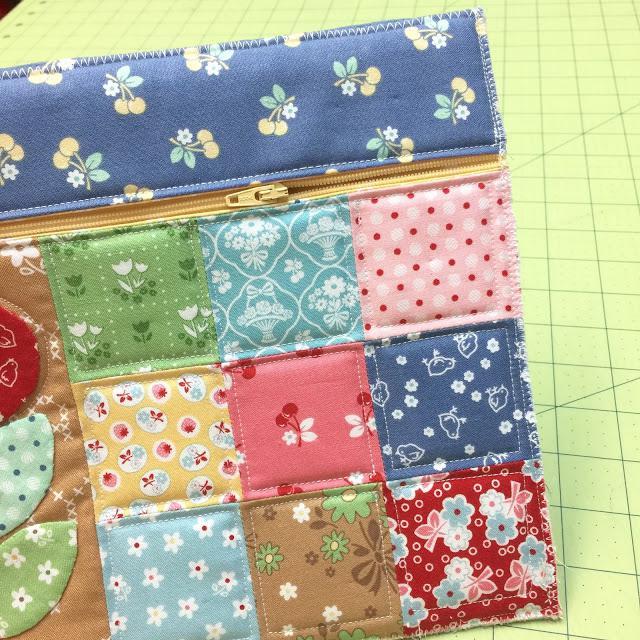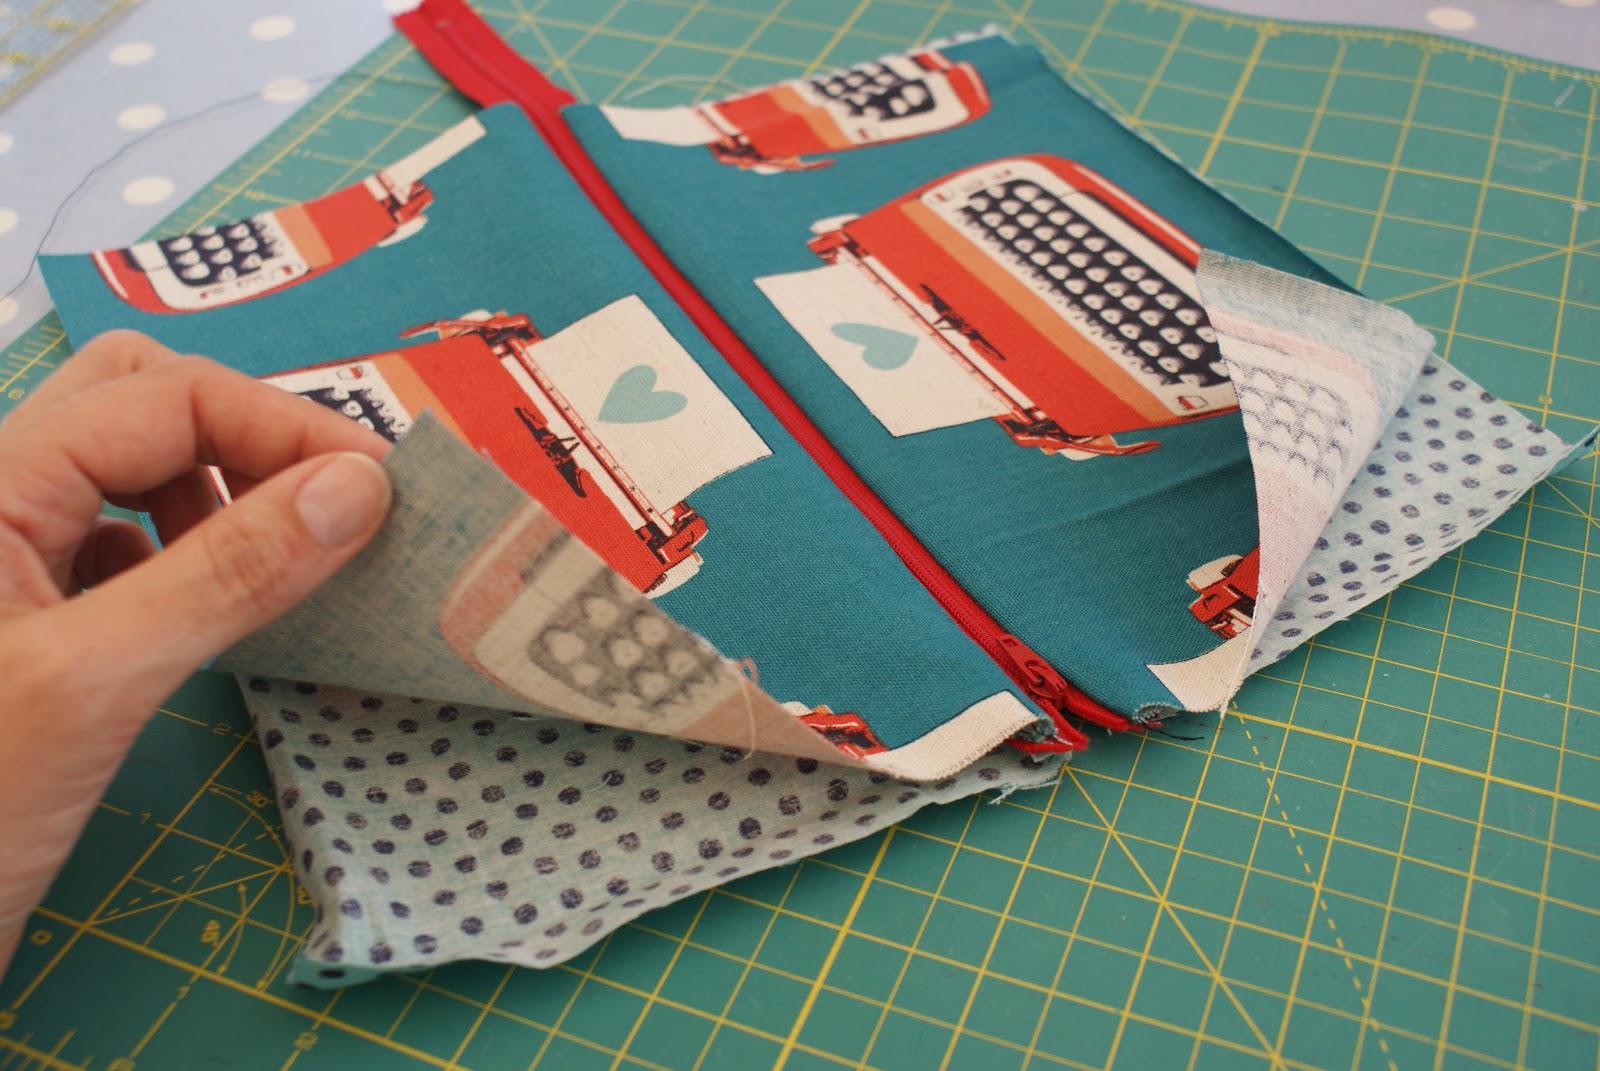The first image is the image on the left, the second image is the image on the right. For the images displayed, is the sentence "There are at least 3 zipper pouches in the right image." factually correct? Answer yes or no. No. 